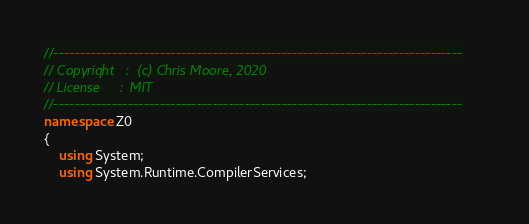<code> <loc_0><loc_0><loc_500><loc_500><_C#_>//-----------------------------------------------------------------------------
// Copyright   :  (c) Chris Moore, 2020
// License     :  MIT
//-----------------------------------------------------------------------------
namespace Z0
{
    using System;
    using System.Runtime.CompilerServices;
</code> 